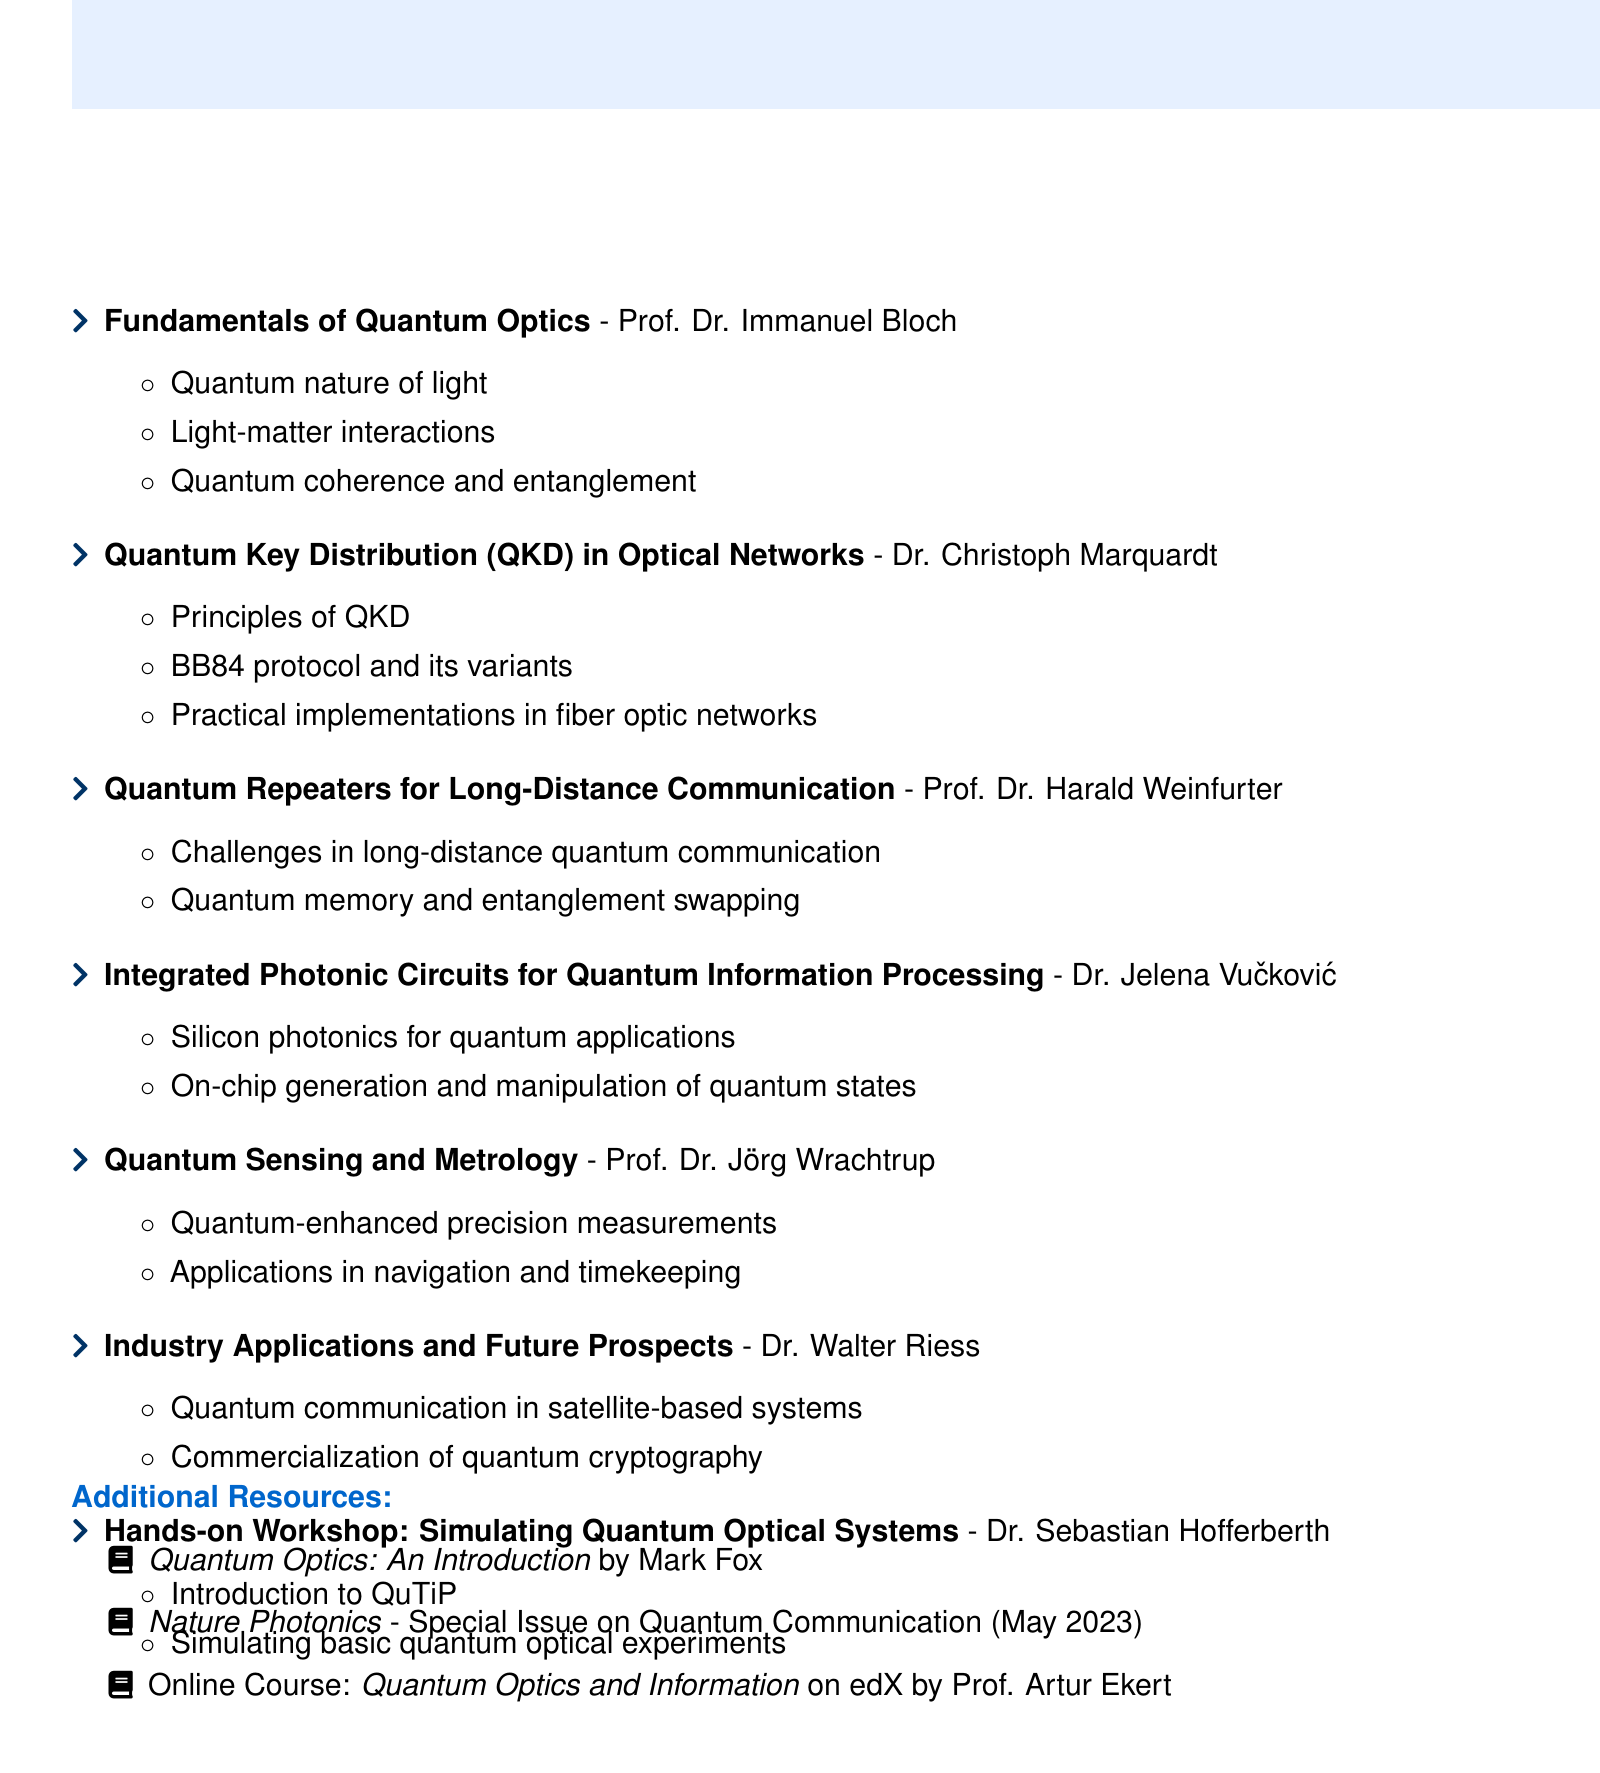What is the title of the seminar? The title of the seminar is specifically mentioned at the beginning of the document.
Answer: Quantum Optics in Communication: Cutting-Edge Developments and Applications Who is the speaker for the session on Quantum Key Distribution? The speaker's name for the Quantum Key Distribution session is listed directly in the document.
Answer: Dr. Christoph Marquardt On which dates is the seminar scheduled? The dates are clearly provided in the seminar details section of the document.
Answer: October 15-16, 2023 What is one of the topics covered in the session about Integrated Photonic Circuits? The document lists several specific topics under this session.
Answer: Silicon photonics for quantum applications Which university is Dr. Jelena Vučković affiliated with? The session details specify the institution associated with Dr. Vučković.
Answer: Stanford University What type of resource is "Quantum Optics: An Introduction"? This information type is explicitly mentioned in the additional resources section.
Answer: Book How many sessions are listed in the agenda? The total number of sessions is summarized in the format of a list in the document.
Answer: Seven 